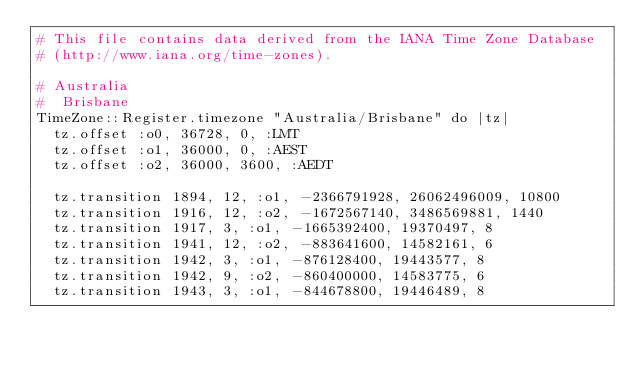<code> <loc_0><loc_0><loc_500><loc_500><_Crystal_># This file contains data derived from the IANA Time Zone Database
# (http://www.iana.org/time-zones).

# Australia
#  Brisbane
TimeZone::Register.timezone "Australia/Brisbane" do |tz|
  tz.offset :o0, 36728, 0, :LMT
  tz.offset :o1, 36000, 0, :AEST
  tz.offset :o2, 36000, 3600, :AEDT
  
  tz.transition 1894, 12, :o1, -2366791928, 26062496009, 10800
  tz.transition 1916, 12, :o2, -1672567140, 3486569881, 1440
  tz.transition 1917, 3, :o1, -1665392400, 19370497, 8
  tz.transition 1941, 12, :o2, -883641600, 14582161, 6
  tz.transition 1942, 3, :o1, -876128400, 19443577, 8
  tz.transition 1942, 9, :o2, -860400000, 14583775, 6
  tz.transition 1943, 3, :o1, -844678800, 19446489, 8</code> 